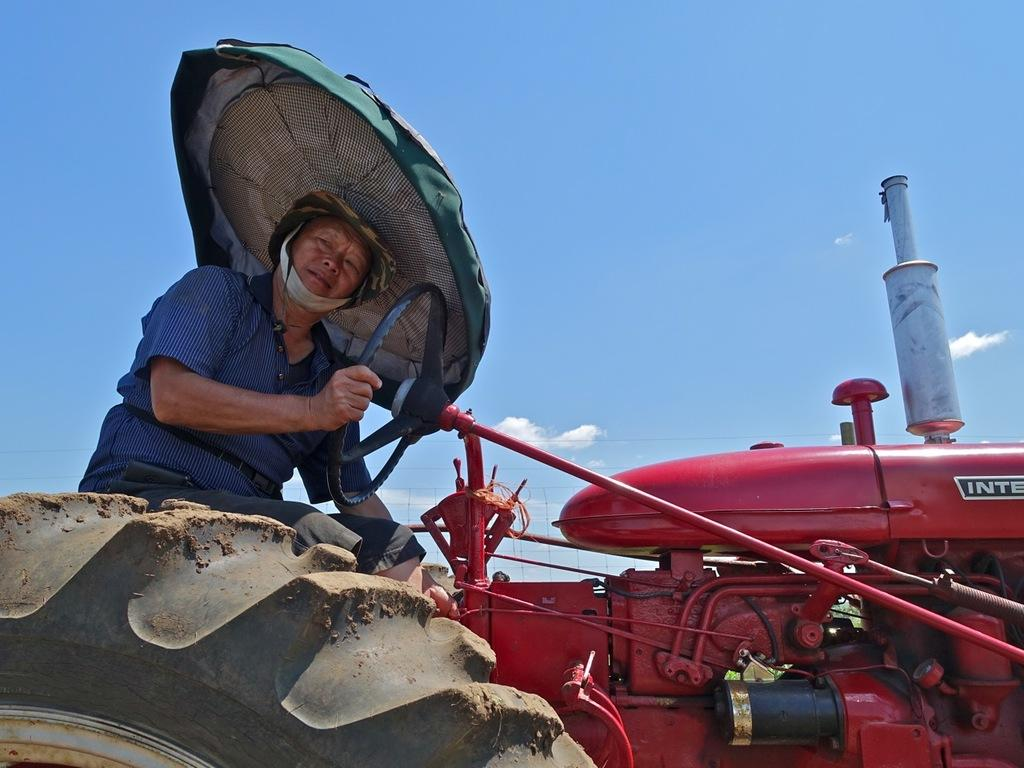Who is present in the image? There is a woman in the image. What is the woman wearing on her head? The woman is wearing a hat. What is the woman sitting on in the image? The woman is sitting in a tractor. What can be seen in the background of the image? The sky is visible in the image. How would you describe the weather based on the sky in the image? The sky appears to be cloudy in the image. What type of grain is the woman harvesting in the image? There is no grain present in the image, nor is there any indication that the woman is harvesting anything. 